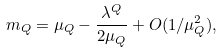<formula> <loc_0><loc_0><loc_500><loc_500>m _ { Q } = \mu _ { Q } - \frac { \lambda ^ { Q } } { 2 \mu _ { Q } } + O ( 1 / \mu _ { Q } ^ { 2 } ) ,</formula> 